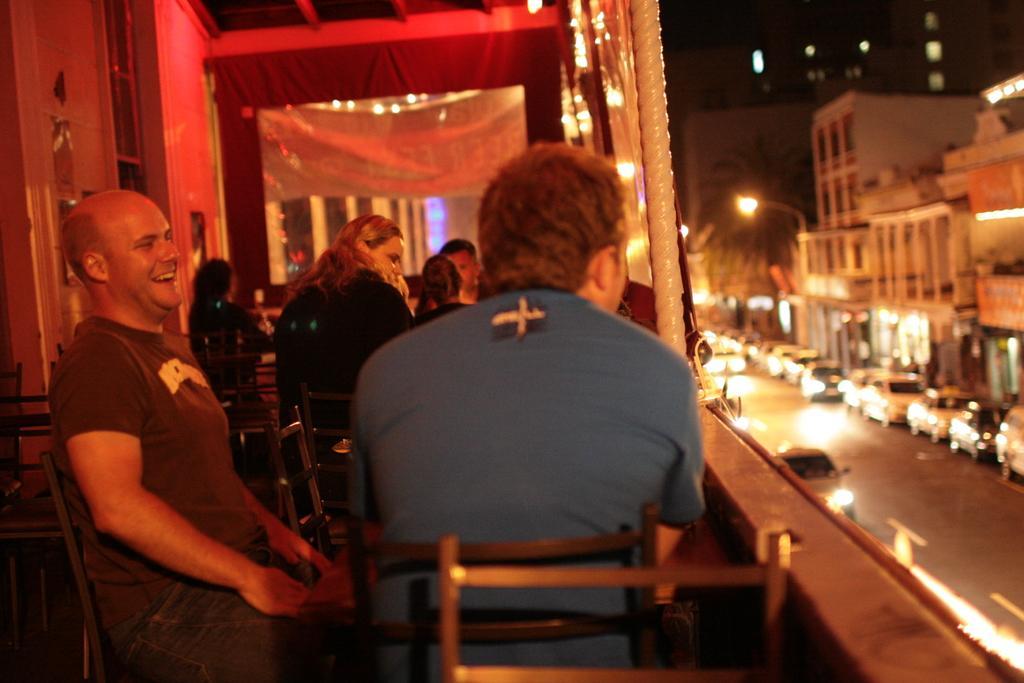How would you summarize this image in a sentence or two? In this picture I can observe some people sitting on the chairs. On the right side I can observe road and some vehicles on the road. In the background I can observe buildings. 